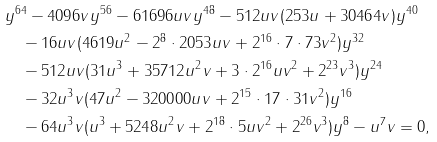<formula> <loc_0><loc_0><loc_500><loc_500>& y ^ { 6 4 } - 4 0 9 6 v y ^ { 5 6 } - 6 1 6 9 6 u v y ^ { 4 8 } - 5 1 2 u v ( 2 5 3 u + 3 0 4 6 4 v ) y ^ { 4 0 } \\ & \quad - 1 6 u v ( 4 6 1 9 u ^ { 2 } - 2 ^ { 8 } \cdot 2 0 5 3 u v + 2 ^ { 1 6 } \cdot 7 \cdot 7 3 v ^ { 2 } ) y ^ { 3 2 } \\ & \quad - 5 1 2 u v ( 3 1 u ^ { 3 } + 3 5 7 1 2 u ^ { 2 } v + 3 \cdot 2 ^ { 1 6 } u v ^ { 2 } + 2 ^ { 2 3 } v ^ { 3 } ) y ^ { 2 4 } \\ & \quad - 3 2 u ^ { 3 } v ( 4 7 u ^ { 2 } - 3 2 0 0 0 0 u v + 2 ^ { 1 5 } \cdot 1 7 \cdot 3 1 v ^ { 2 } ) y ^ { 1 6 } \\ & \quad - 6 4 u ^ { 3 } v ( u ^ { 3 } + 5 2 4 8 u ^ { 2 } v + 2 ^ { 1 8 } \cdot 5 u v ^ { 2 } + 2 ^ { 2 6 } v ^ { 3 } ) y ^ { 8 } - u ^ { 7 } v = 0 ,</formula> 